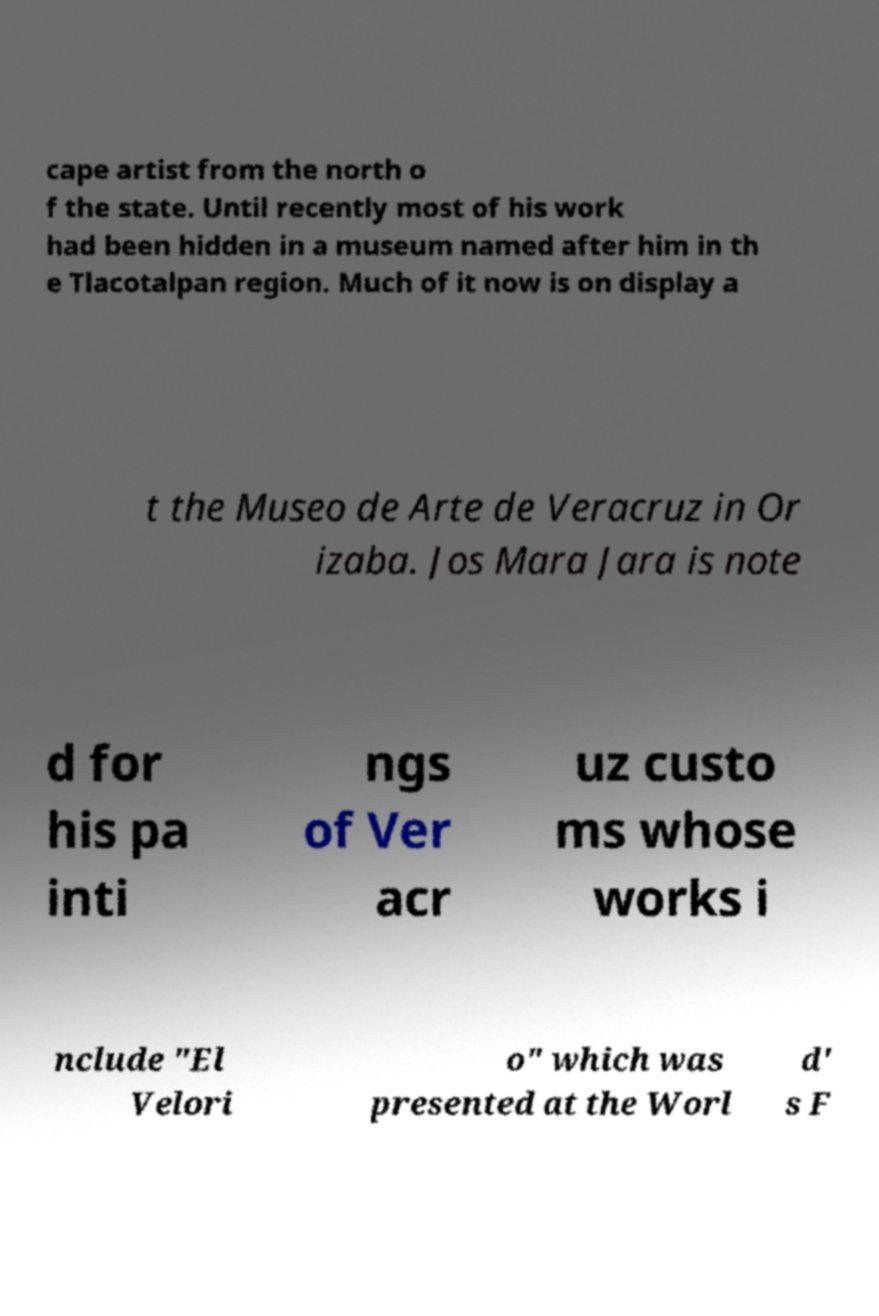There's text embedded in this image that I need extracted. Can you transcribe it verbatim? cape artist from the north o f the state. Until recently most of his work had been hidden in a museum named after him in th e Tlacotalpan region. Much of it now is on display a t the Museo de Arte de Veracruz in Or izaba. Jos Mara Jara is note d for his pa inti ngs of Ver acr uz custo ms whose works i nclude "El Velori o" which was presented at the Worl d' s F 